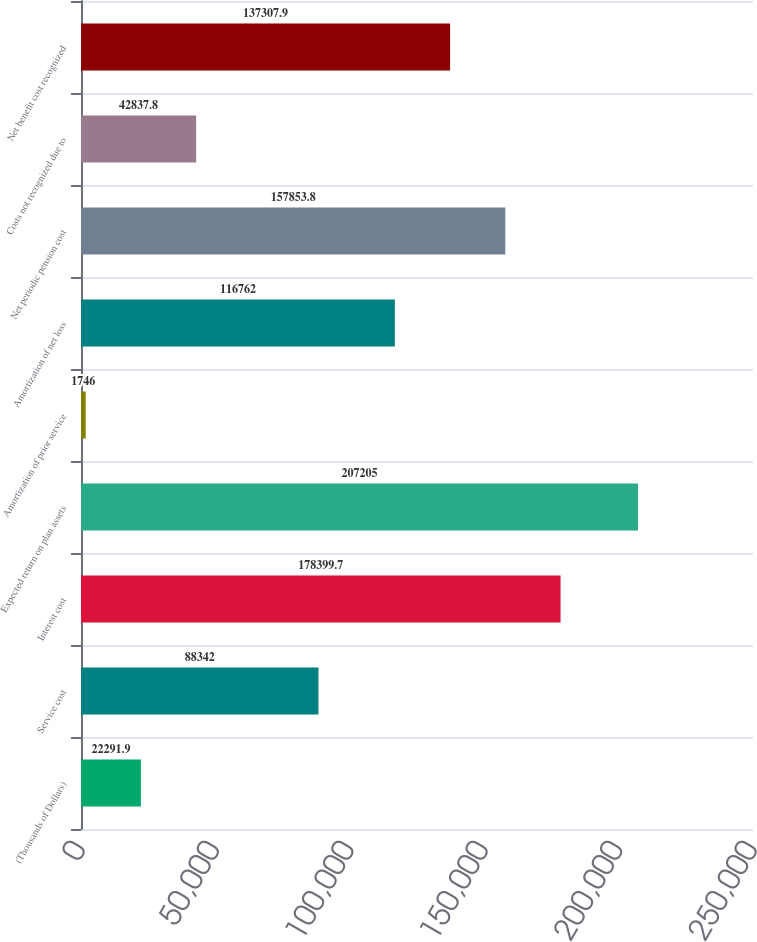Convert chart. <chart><loc_0><loc_0><loc_500><loc_500><bar_chart><fcel>(Thousands of Dollars)<fcel>Service cost<fcel>Interest cost<fcel>Expected return on plan assets<fcel>Amortization of prior service<fcel>Amortization of net loss<fcel>Net periodic pension cost<fcel>Costs not recognized due to<fcel>Net benefit cost recognized<nl><fcel>22291.9<fcel>88342<fcel>178400<fcel>207205<fcel>1746<fcel>116762<fcel>157854<fcel>42837.8<fcel>137308<nl></chart> 